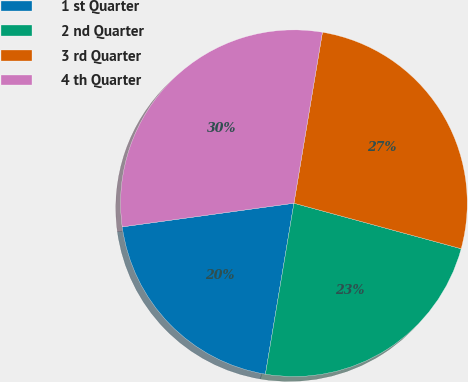Convert chart. <chart><loc_0><loc_0><loc_500><loc_500><pie_chart><fcel>1 st Quarter<fcel>2 nd Quarter<fcel>3 rd Quarter<fcel>4 th Quarter<nl><fcel>20.19%<fcel>23.4%<fcel>26.6%<fcel>29.81%<nl></chart> 